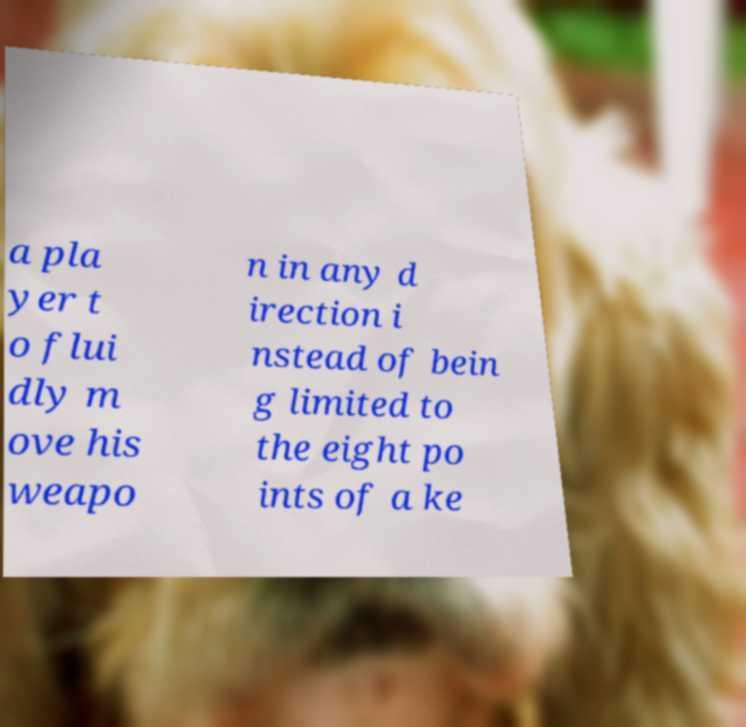What messages or text are displayed in this image? I need them in a readable, typed format. a pla yer t o flui dly m ove his weapo n in any d irection i nstead of bein g limited to the eight po ints of a ke 